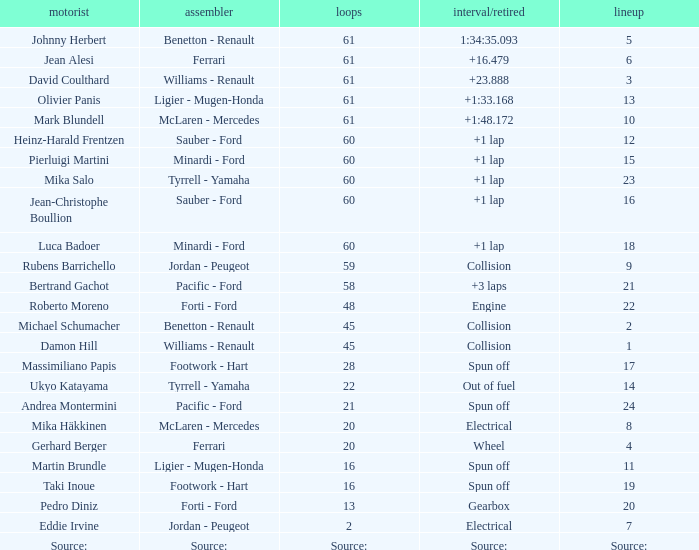What's the time/retired for a grid of 14? Out of fuel. 